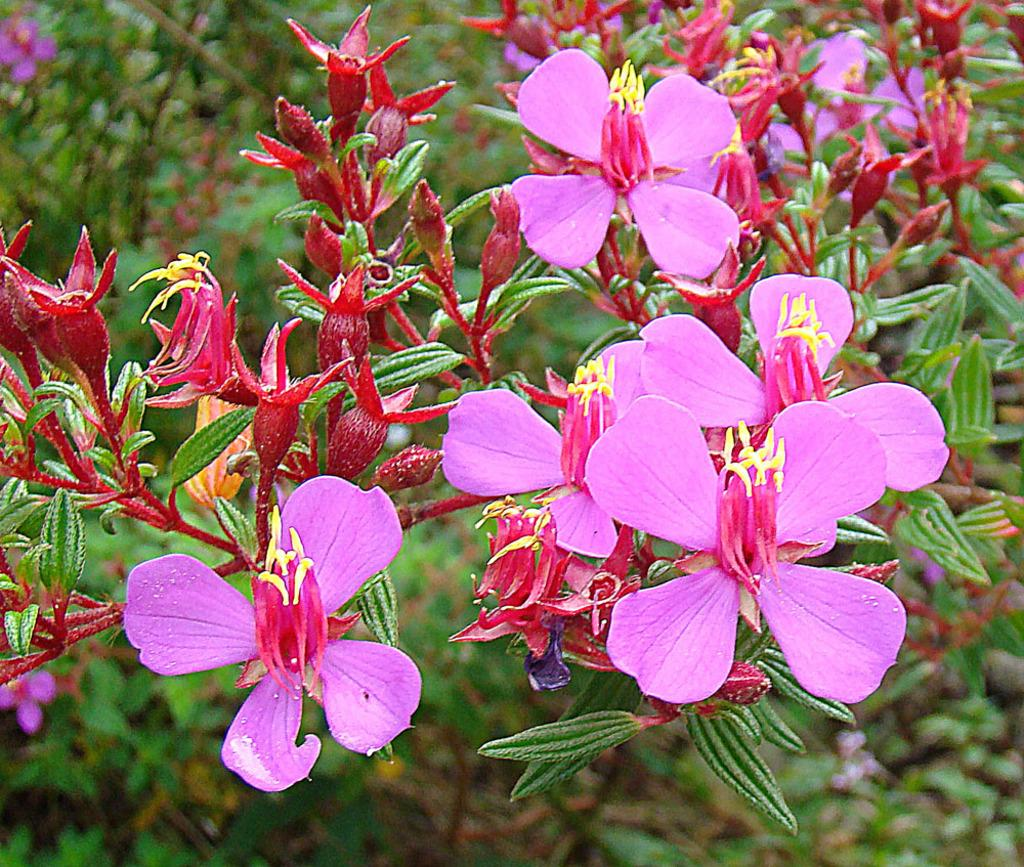What type of flowers can be seen in the image? There are pink flowers in the image. What other features can be observed on the flowers? There are red buds on the flowers. What color are the leaves in the image? The leaves in the image are green. How would you describe the background of the image? The background of the image is blurry. Can you see the border of the sea in the image? There is no sea or border present in the image; it features flowers with green leaves and red buds against a blurry background. 